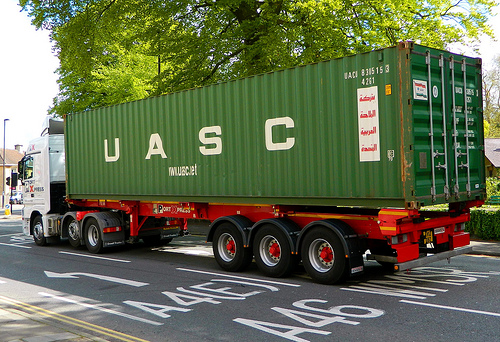What if the truck's container held a miraculous invention that revolutionized the world? If the truck's container held a miraculous invention, it could be a revolutionary clean energy source, such as a compact fusion reactor. This invention could provide limitless energy with no environmental damage, triggering a global transformation. Nations would shift to green economies; cities would be transformed into tech utopias powered by this clean energy source. The truck in the image would be a symbol of this monumental shift, carrying hope and a sustainable future inside a simple green container. What would be the steps to distribute such an invention globally? Distributing such a groundbreaking invention would require rigorous planning. Initially, creation of prototypes and testing at secure facilities would ensure safety and efficiency. A global collaboration between governments, scientists, and industry leaders would be crucial for large-scale manufacturing and logistics planning. Setting up production plants internationally, establishing distribution networks, and training professionals would all be part of the strategic deployment. Public education campaigns would be enacted to facilitate understanding and acceptance. Finally, international policies and agreements would govern its use to ensure equitable access and environmental protection. 